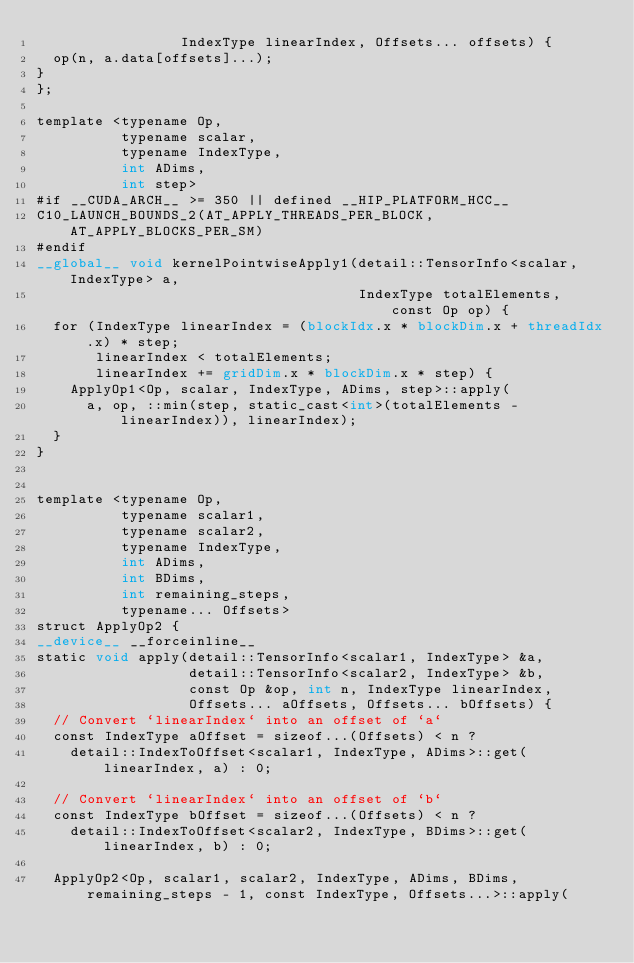<code> <loc_0><loc_0><loc_500><loc_500><_Cuda_>                 IndexType linearIndex, Offsets... offsets) {
  op(n, a.data[offsets]...);
}
};

template <typename Op,
          typename scalar,
          typename IndexType,
          int ADims,
          int step>
#if __CUDA_ARCH__ >= 350 || defined __HIP_PLATFORM_HCC__
C10_LAUNCH_BOUNDS_2(AT_APPLY_THREADS_PER_BLOCK, AT_APPLY_BLOCKS_PER_SM)
#endif
__global__ void kernelPointwiseApply1(detail::TensorInfo<scalar, IndexType> a,
                                      IndexType totalElements, const Op op) {
  for (IndexType linearIndex = (blockIdx.x * blockDim.x + threadIdx.x) * step;
       linearIndex < totalElements;
       linearIndex += gridDim.x * blockDim.x * step) {
    ApplyOp1<Op, scalar, IndexType, ADims, step>::apply(
      a, op, ::min(step, static_cast<int>(totalElements - linearIndex)), linearIndex);
  }
}


template <typename Op,
          typename scalar1,
          typename scalar2,
          typename IndexType,
          int ADims,
          int BDims,
          int remaining_steps,
          typename... Offsets>
struct ApplyOp2 {
__device__ __forceinline__
static void apply(detail::TensorInfo<scalar1, IndexType> &a,
                  detail::TensorInfo<scalar2, IndexType> &b,
                  const Op &op, int n, IndexType linearIndex,
                  Offsets... aOffsets, Offsets... bOffsets) {
  // Convert `linearIndex` into an offset of `a`
  const IndexType aOffset = sizeof...(Offsets) < n ?
    detail::IndexToOffset<scalar1, IndexType, ADims>::get(linearIndex, a) : 0;

  // Convert `linearIndex` into an offset of `b`
  const IndexType bOffset = sizeof...(Offsets) < n ?
    detail::IndexToOffset<scalar2, IndexType, BDims>::get(linearIndex, b) : 0;

  ApplyOp2<Op, scalar1, scalar2, IndexType, ADims, BDims, remaining_steps - 1, const IndexType, Offsets...>::apply(</code> 